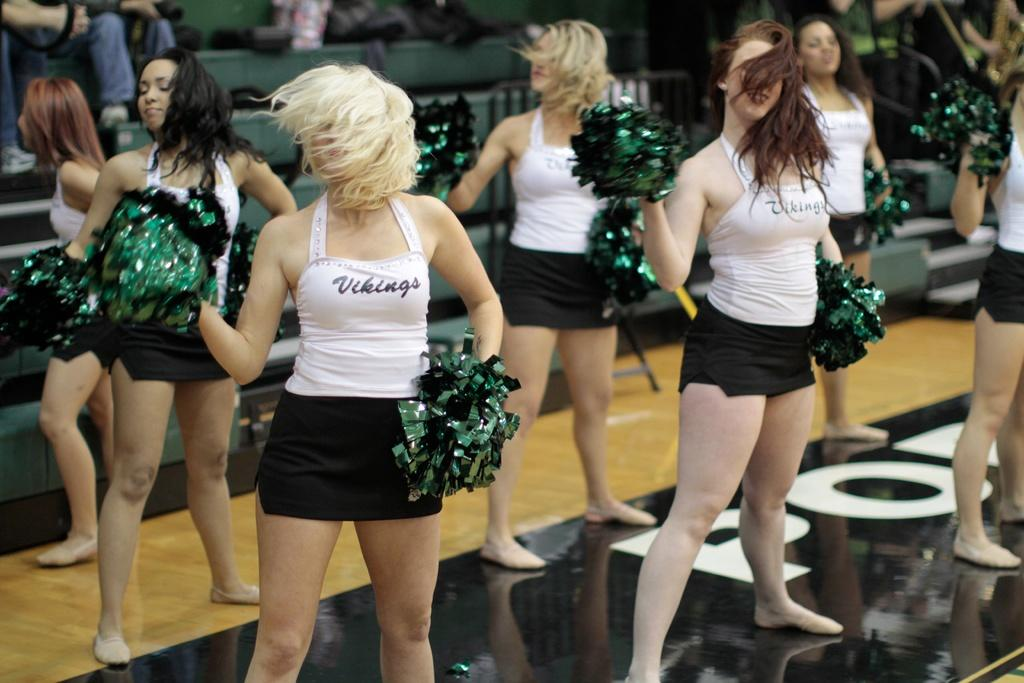<image>
Share a concise interpretation of the image provided. A group of cheerleaders wear white and black vikings uniforms. 